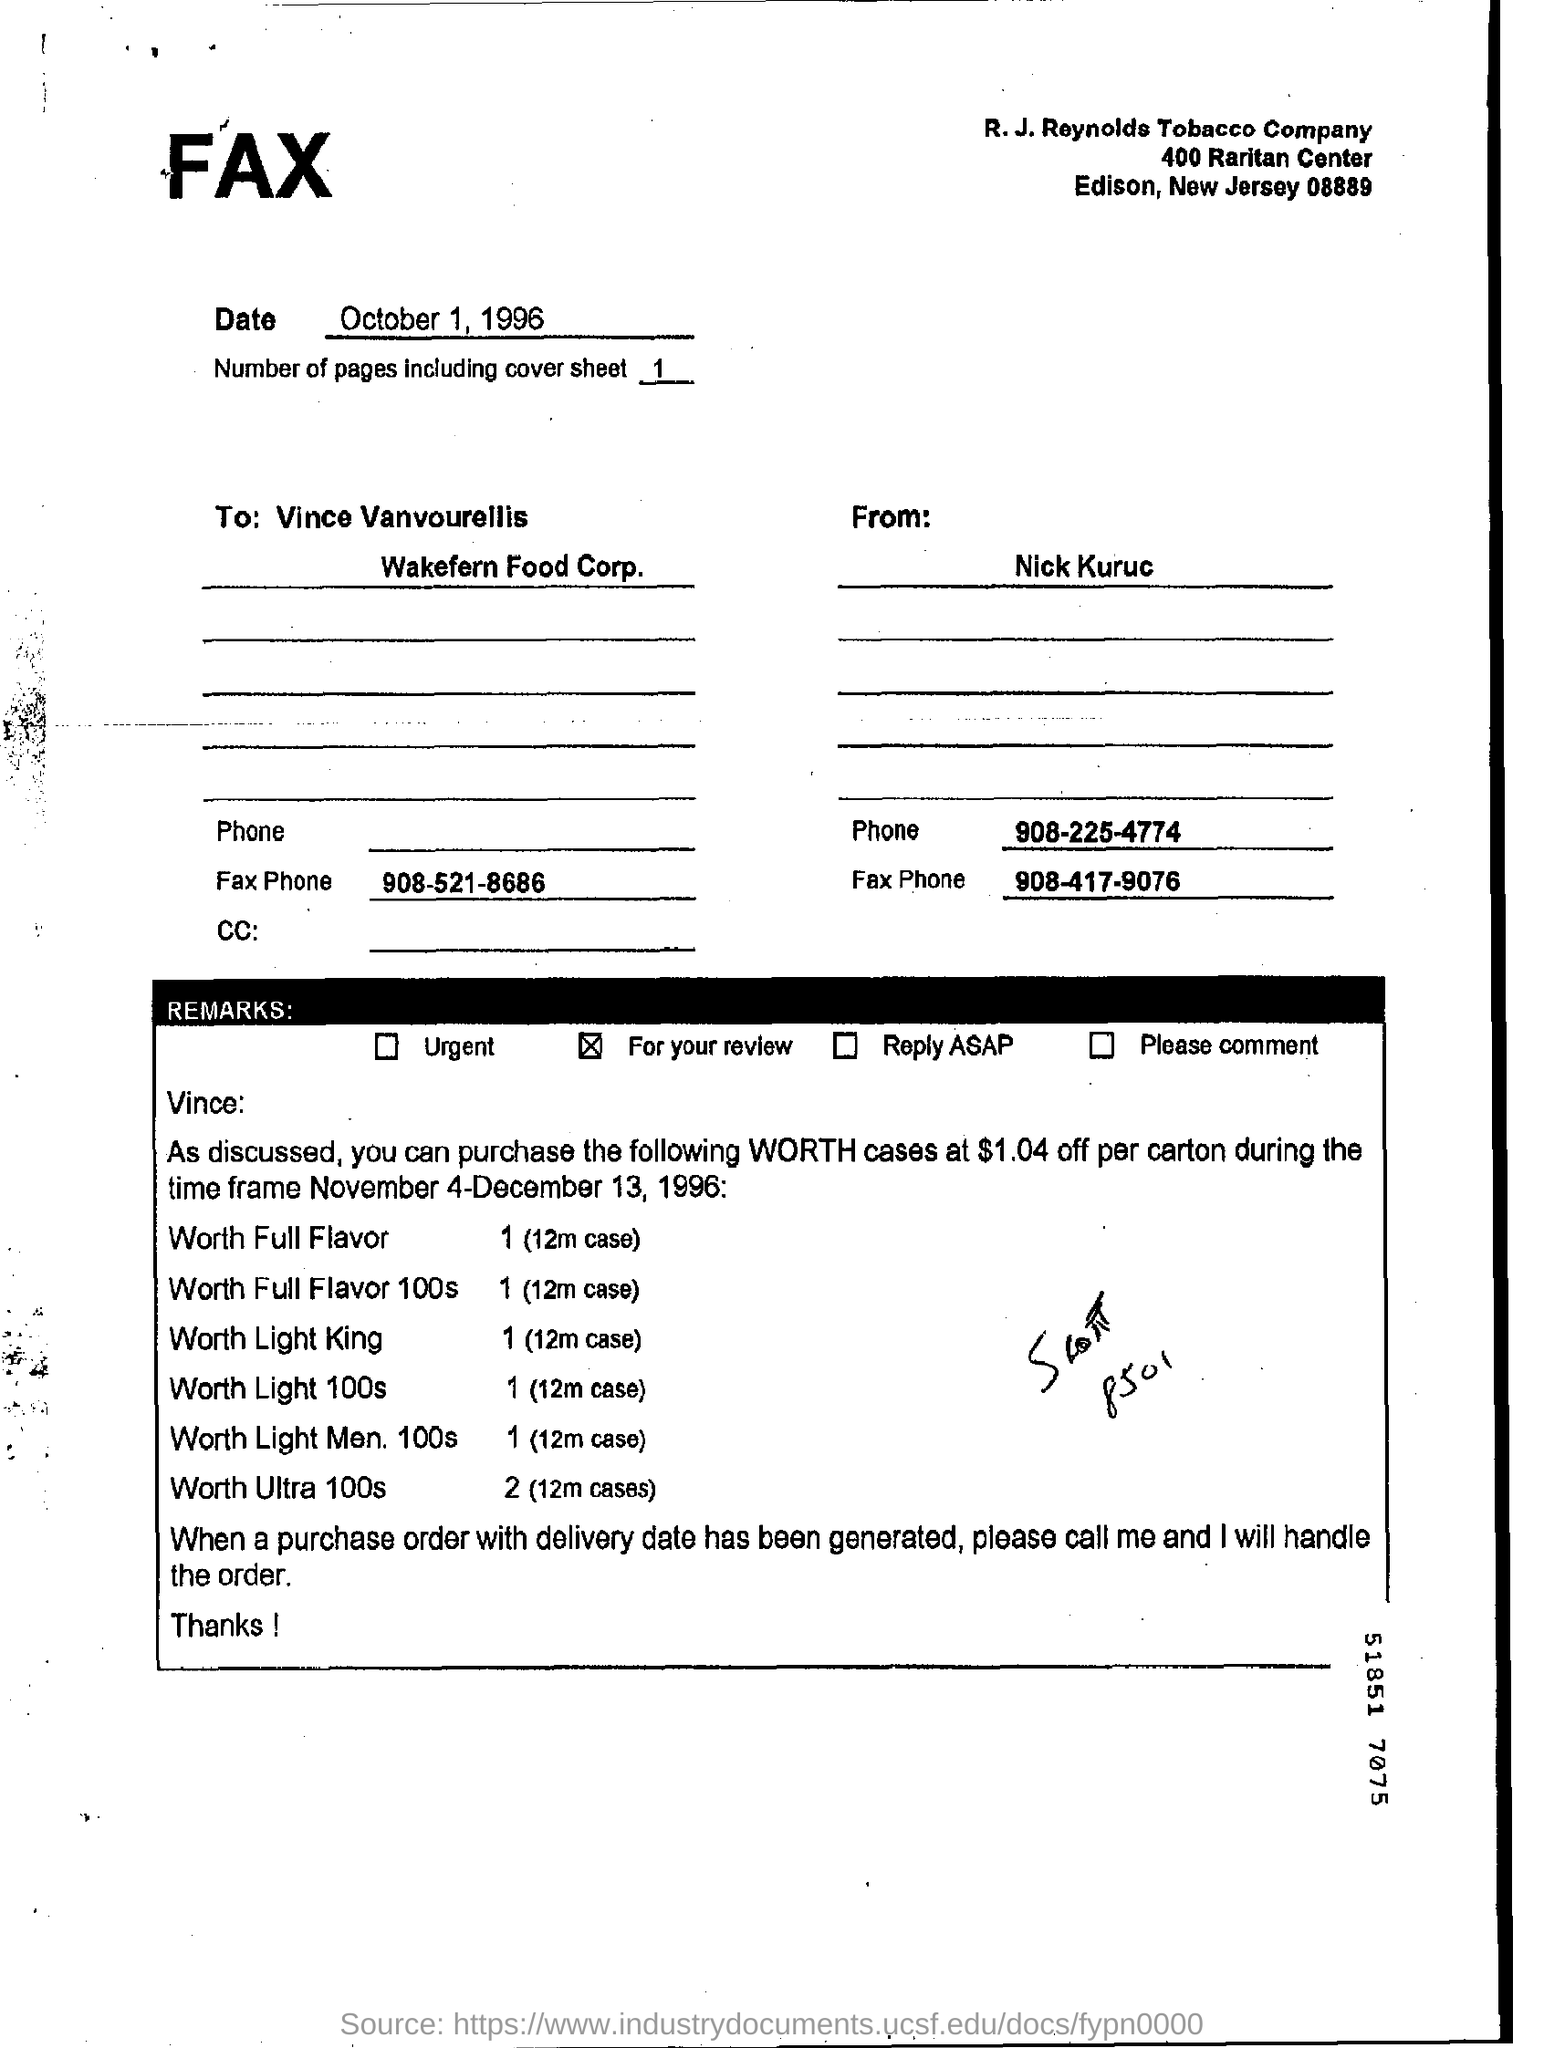When is the document faxed?
Give a very brief answer. October 1,1996. Who faxed the document?
Keep it short and to the point. Nick  kuruc. Which remark item is marked?
Provide a short and direct response. For your review. Under "Remarks" which option is marked?
Keep it short and to the point. For your review. 